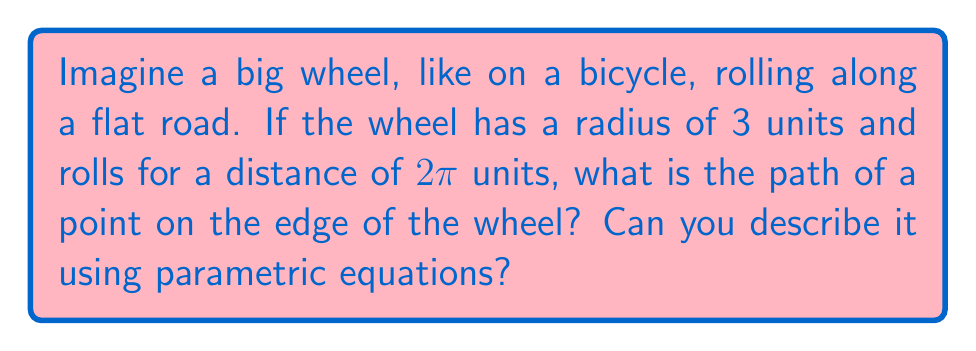Help me with this question. Let's break this down step-by-step:

1) When a wheel rolls, a point on its edge traces a curve called a cycloid.

2) To describe this curve, we need two components:
   - The horizontal movement of the wheel's center
   - The circular motion of the point around the center

3) Let's use the parameter $t$, where $0 \leq t \leq 2\pi$:
   - $t = 0$ is when the point touches the ground
   - $t = 2\pi$ is when it completes one full revolution

4) The horizontal movement of the center is simple:
   $x = 3t$ (radius * angle)

5) The vertical movement is more complex:
   - The center of the wheel is always 3 units above the ground
   - The point moves up and down by 3 units (the radius) as the wheel turns

6) We can express this vertical movement as:
   $y = 3 - 3\cos(t)$

7) Combining these, we get the parametric equations:
   $$x = 3t$$
   $$y = 3 - 3\cos(t)$$

8) These equations describe the path of the point for $0 \leq t \leq 2\pi$.

[asy]
import graph;
size(200,100);
real x(real t) {return 3t;}
real y(real t) {return 3-3cos(t);}
draw(graph(x,y,0,2pi));
xaxis("x");
yaxis("y");
[/asy]
Answer: The path of the point is described by the parametric equations:
$$x = 3t$$
$$y = 3 - 3\cos(t)$$
where $0 \leq t \leq 2\pi$ 